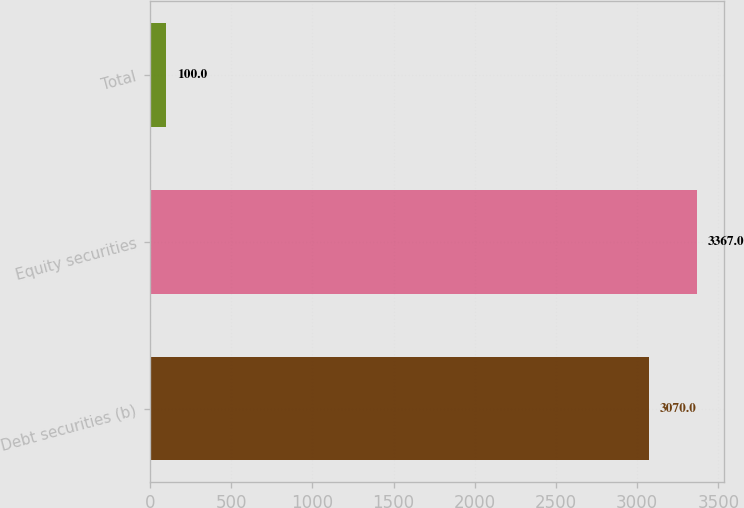Convert chart to OTSL. <chart><loc_0><loc_0><loc_500><loc_500><bar_chart><fcel>Debt securities (b)<fcel>Equity securities<fcel>Total<nl><fcel>3070<fcel>3367<fcel>100<nl></chart> 